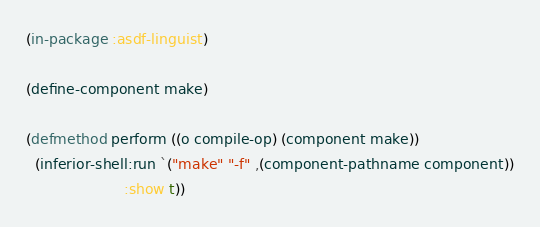Convert code to text. <code><loc_0><loc_0><loc_500><loc_500><_Lisp_>(in-package :asdf-linguist)

(define-component make)

(defmethod perform ((o compile-op) (component make))
  (inferior-shell:run `("make" "-f" ,(component-pathname component))
                      :show t))
</code> 